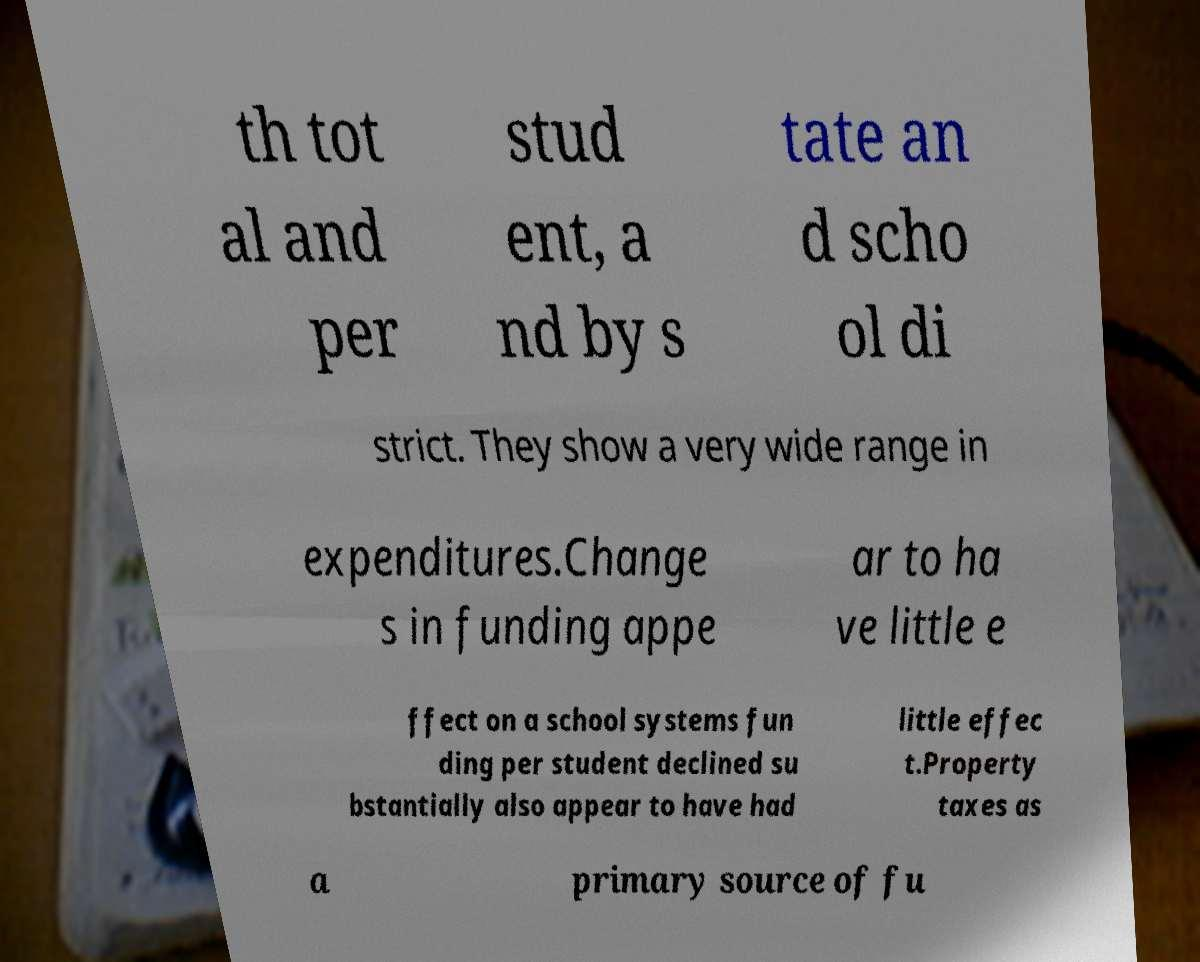Please identify and transcribe the text found in this image. th tot al and per stud ent, a nd by s tate an d scho ol di strict. They show a very wide range in expenditures.Change s in funding appe ar to ha ve little e ffect on a school systems fun ding per student declined su bstantially also appear to have had little effec t.Property taxes as a primary source of fu 